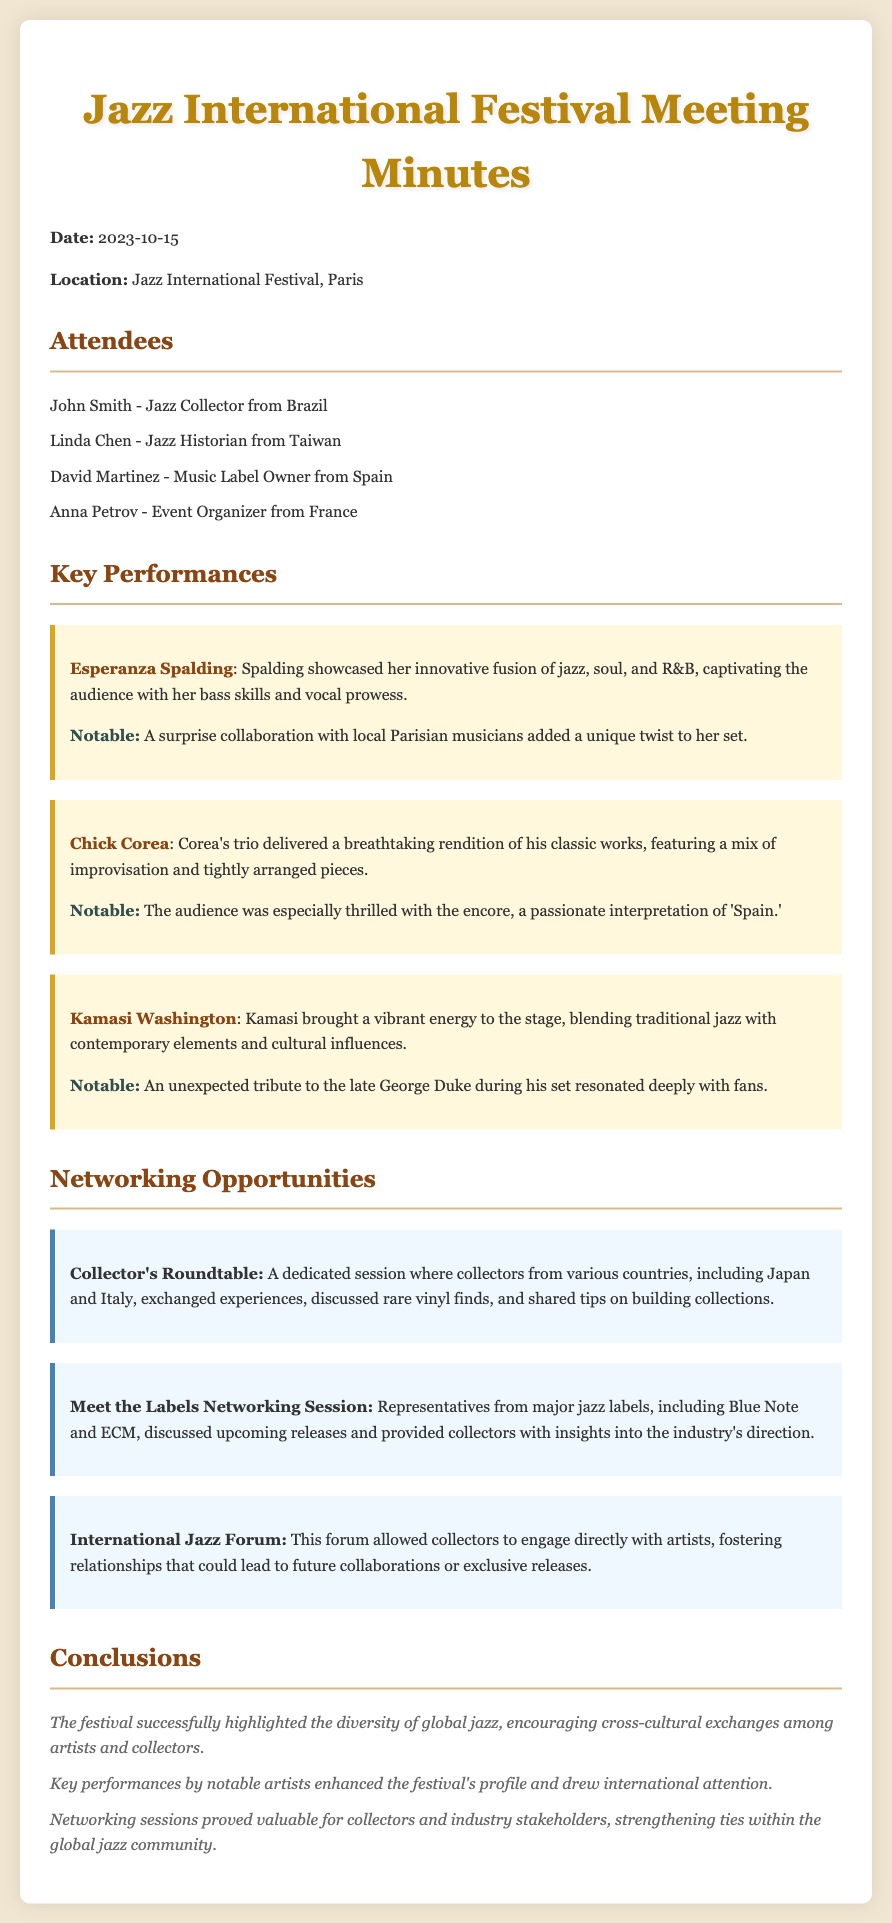What date was the meeting held? The date is explicitly mentioned in the document as 2023-10-15.
Answer: 2023-10-15 Who was one of the attendees from Taiwan? The document lists Linda Chen as the attendee from Taiwan.
Answer: Linda Chen What genre did Esperanza Spalding incorporate in her performance? The document states that she showcased her fusion of jazz, soul, and R&B.
Answer: jazz, soul, and R&B Which notable jazz label was mentioned during the networking session? The document highlights Blue Note and ECM as major jazz labels discussed.
Answer: Blue Note What was a notable moment during Kamasi Washington's performance? The document notes an unexpected tribute to the late George Duke.
Answer: Tribute to George Duke What was the purpose of the Collector's Roundtable? The document describes it as a session for collectors to exchange experiences and tips.
Answer: Exchange experiences and tips How did the festival enhance its profile according to the conclusions? The document indicates that key performances by notable artists enhanced the festival's profile.
Answer: Key performances by notable artists What was the focus of the International Jazz Forum? The forum enabled collectors to engage directly with artists, as stated in the document.
Answer: Engage directly with artists 